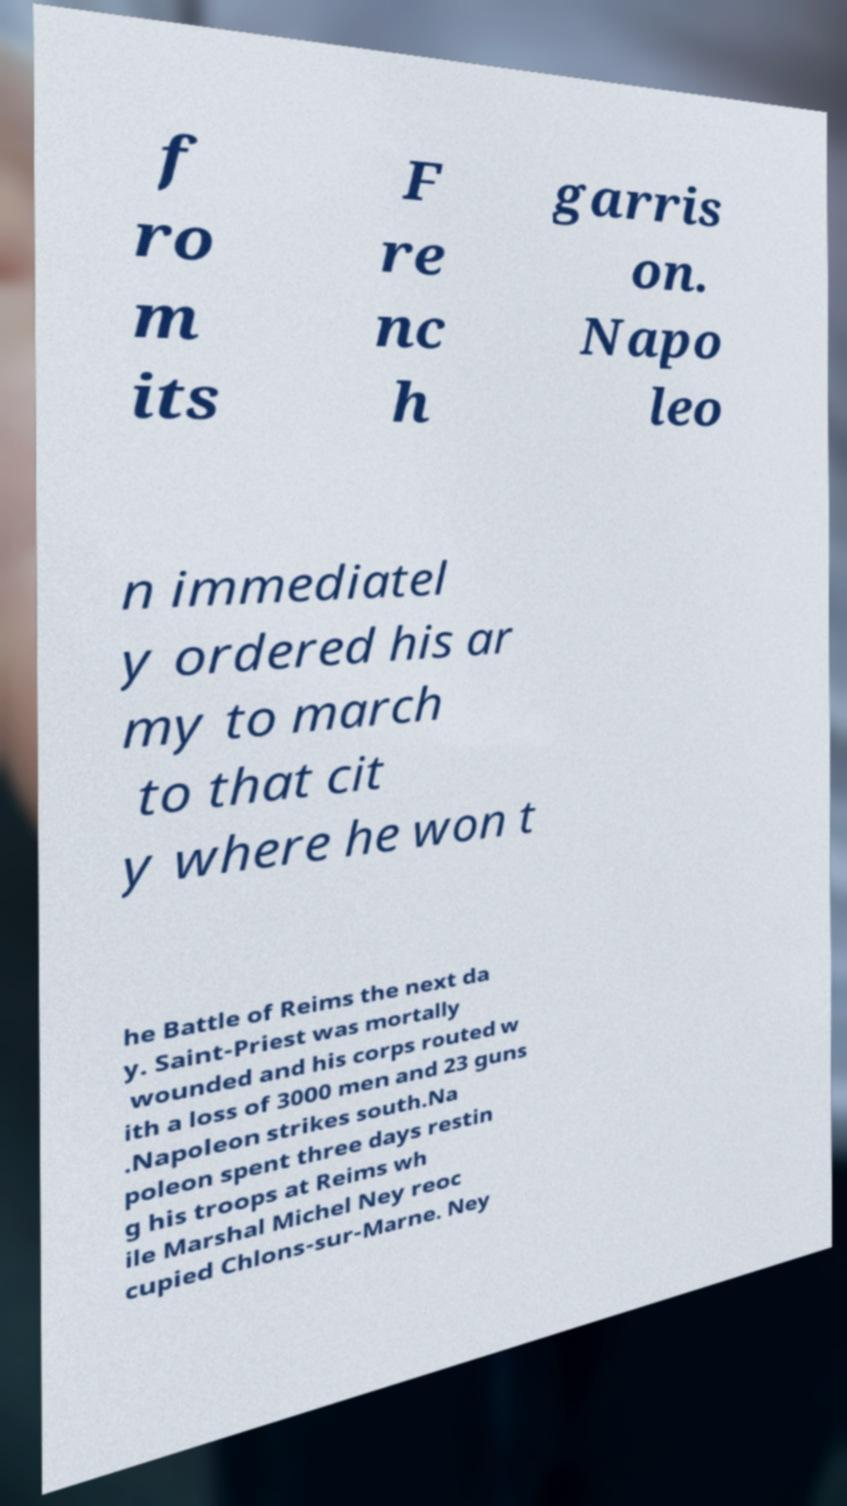Please read and relay the text visible in this image. What does it say? f ro m its F re nc h garris on. Napo leo n immediatel y ordered his ar my to march to that cit y where he won t he Battle of Reims the next da y. Saint-Priest was mortally wounded and his corps routed w ith a loss of 3000 men and 23 guns .Napoleon strikes south.Na poleon spent three days restin g his troops at Reims wh ile Marshal Michel Ney reoc cupied Chlons-sur-Marne. Ney 